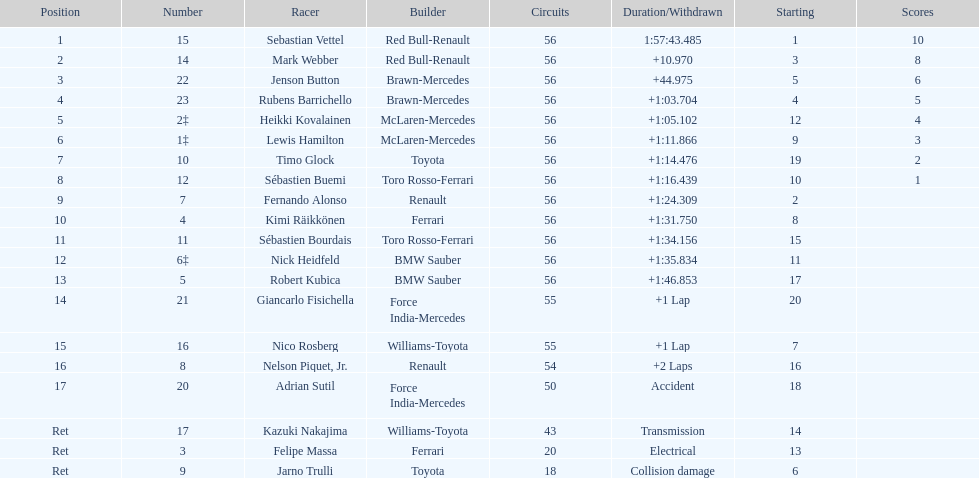Which driver is the only driver who retired because of collision damage? Jarno Trulli. 